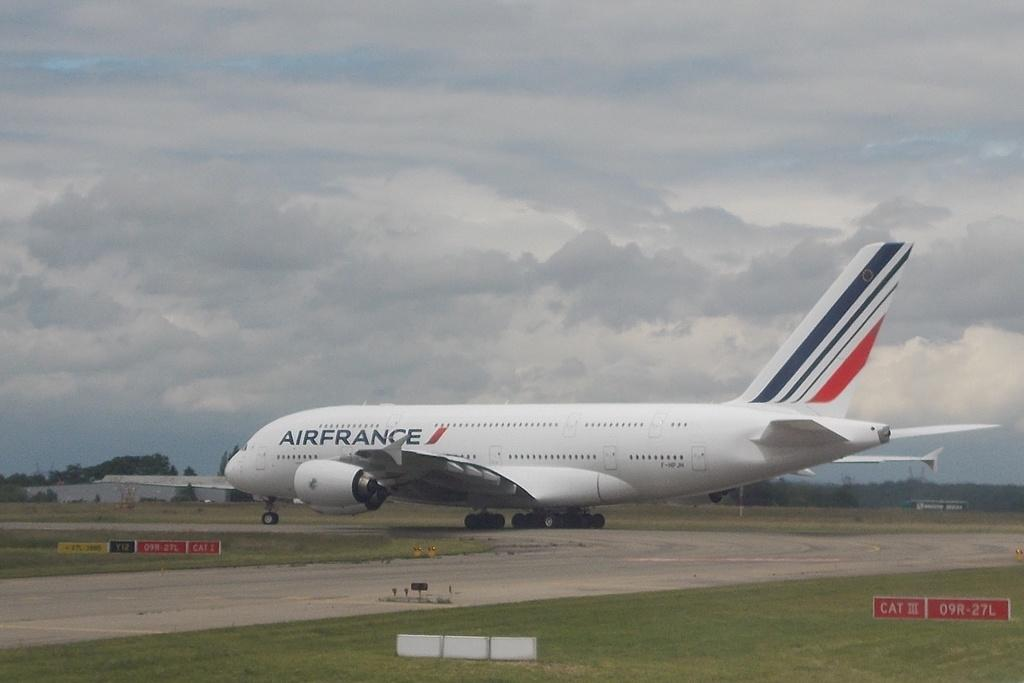<image>
Give a short and clear explanation of the subsequent image. A large air france jet on runway 09R-27L on a cloudy day. 